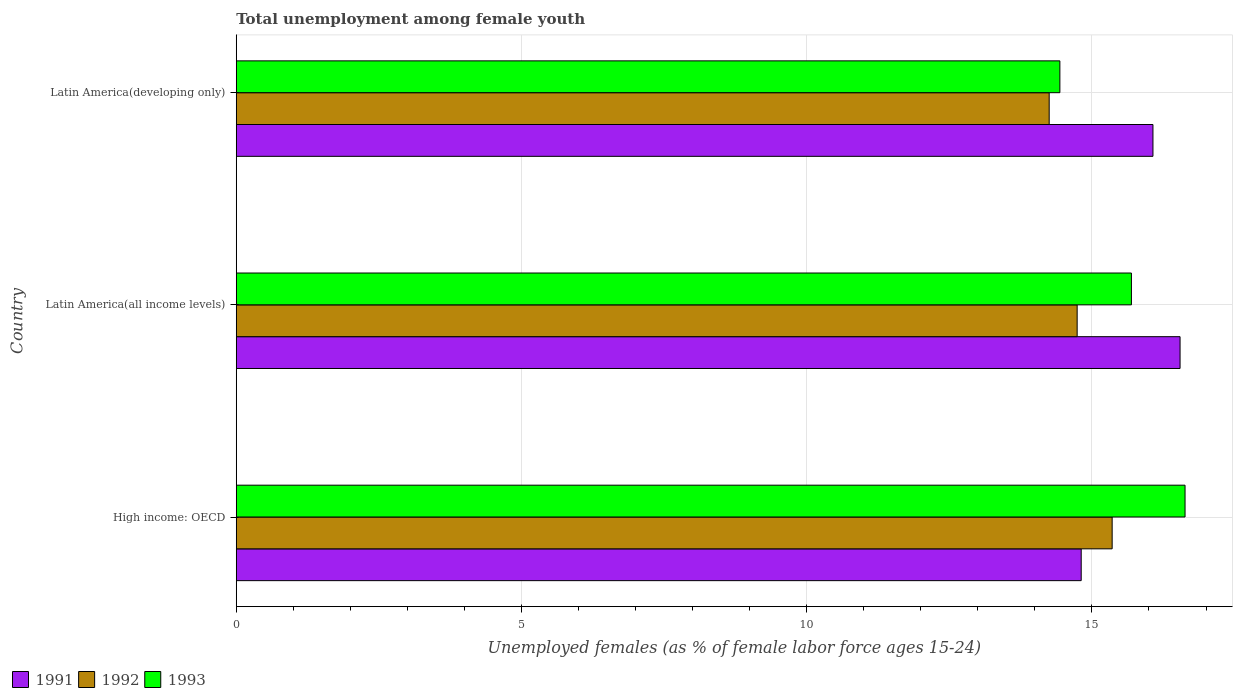How many groups of bars are there?
Give a very brief answer. 3. How many bars are there on the 2nd tick from the top?
Provide a succinct answer. 3. What is the label of the 2nd group of bars from the top?
Your answer should be very brief. Latin America(all income levels). What is the percentage of unemployed females in in 1992 in Latin America(all income levels)?
Make the answer very short. 14.74. Across all countries, what is the maximum percentage of unemployed females in in 1991?
Your answer should be very brief. 16.54. Across all countries, what is the minimum percentage of unemployed females in in 1992?
Offer a terse response. 14.25. In which country was the percentage of unemployed females in in 1992 maximum?
Your response must be concise. High income: OECD. In which country was the percentage of unemployed females in in 1992 minimum?
Offer a very short reply. Latin America(developing only). What is the total percentage of unemployed females in in 1993 in the graph?
Make the answer very short. 46.76. What is the difference between the percentage of unemployed females in in 1992 in High income: OECD and that in Latin America(all income levels)?
Your answer should be very brief. 0.61. What is the difference between the percentage of unemployed females in in 1992 in High income: OECD and the percentage of unemployed females in in 1991 in Latin America(developing only)?
Your answer should be compact. -0.72. What is the average percentage of unemployed females in in 1991 per country?
Keep it short and to the point. 15.81. What is the difference between the percentage of unemployed females in in 1991 and percentage of unemployed females in in 1993 in Latin America(developing only)?
Offer a terse response. 1.63. In how many countries, is the percentage of unemployed females in in 1993 greater than 15 %?
Your response must be concise. 2. What is the ratio of the percentage of unemployed females in in 1992 in High income: OECD to that in Latin America(developing only)?
Give a very brief answer. 1.08. Is the percentage of unemployed females in in 1992 in High income: OECD less than that in Latin America(all income levels)?
Your response must be concise. No. Is the difference between the percentage of unemployed females in in 1991 in High income: OECD and Latin America(developing only) greater than the difference between the percentage of unemployed females in in 1993 in High income: OECD and Latin America(developing only)?
Your response must be concise. No. What is the difference between the highest and the second highest percentage of unemployed females in in 1993?
Give a very brief answer. 0.94. What is the difference between the highest and the lowest percentage of unemployed females in in 1992?
Ensure brevity in your answer.  1.1. How many bars are there?
Make the answer very short. 9. Are all the bars in the graph horizontal?
Your answer should be compact. Yes. Does the graph contain grids?
Provide a short and direct response. Yes. What is the title of the graph?
Make the answer very short. Total unemployment among female youth. Does "1996" appear as one of the legend labels in the graph?
Your answer should be compact. No. What is the label or title of the X-axis?
Make the answer very short. Unemployed females (as % of female labor force ages 15-24). What is the label or title of the Y-axis?
Offer a terse response. Country. What is the Unemployed females (as % of female labor force ages 15-24) in 1991 in High income: OECD?
Make the answer very short. 14.81. What is the Unemployed females (as % of female labor force ages 15-24) of 1992 in High income: OECD?
Keep it short and to the point. 15.35. What is the Unemployed females (as % of female labor force ages 15-24) of 1993 in High income: OECD?
Offer a terse response. 16.63. What is the Unemployed females (as % of female labor force ages 15-24) of 1991 in Latin America(all income levels)?
Offer a very short reply. 16.54. What is the Unemployed females (as % of female labor force ages 15-24) of 1992 in Latin America(all income levels)?
Make the answer very short. 14.74. What is the Unemployed females (as % of female labor force ages 15-24) in 1993 in Latin America(all income levels)?
Offer a very short reply. 15.69. What is the Unemployed females (as % of female labor force ages 15-24) of 1991 in Latin America(developing only)?
Provide a short and direct response. 16.07. What is the Unemployed females (as % of female labor force ages 15-24) in 1992 in Latin America(developing only)?
Provide a succinct answer. 14.25. What is the Unemployed females (as % of female labor force ages 15-24) of 1993 in Latin America(developing only)?
Your answer should be compact. 14.44. Across all countries, what is the maximum Unemployed females (as % of female labor force ages 15-24) in 1991?
Your answer should be very brief. 16.54. Across all countries, what is the maximum Unemployed females (as % of female labor force ages 15-24) in 1992?
Your answer should be compact. 15.35. Across all countries, what is the maximum Unemployed females (as % of female labor force ages 15-24) in 1993?
Ensure brevity in your answer.  16.63. Across all countries, what is the minimum Unemployed females (as % of female labor force ages 15-24) of 1991?
Give a very brief answer. 14.81. Across all countries, what is the minimum Unemployed females (as % of female labor force ages 15-24) in 1992?
Your answer should be compact. 14.25. Across all countries, what is the minimum Unemployed females (as % of female labor force ages 15-24) of 1993?
Ensure brevity in your answer.  14.44. What is the total Unemployed females (as % of female labor force ages 15-24) of 1991 in the graph?
Your answer should be very brief. 47.43. What is the total Unemployed females (as % of female labor force ages 15-24) in 1992 in the graph?
Your answer should be compact. 44.35. What is the total Unemployed females (as % of female labor force ages 15-24) in 1993 in the graph?
Your response must be concise. 46.76. What is the difference between the Unemployed females (as % of female labor force ages 15-24) of 1991 in High income: OECD and that in Latin America(all income levels)?
Give a very brief answer. -1.73. What is the difference between the Unemployed females (as % of female labor force ages 15-24) in 1992 in High income: OECD and that in Latin America(all income levels)?
Your response must be concise. 0.61. What is the difference between the Unemployed females (as % of female labor force ages 15-24) in 1993 in High income: OECD and that in Latin America(all income levels)?
Make the answer very short. 0.94. What is the difference between the Unemployed females (as % of female labor force ages 15-24) of 1991 in High income: OECD and that in Latin America(developing only)?
Give a very brief answer. -1.26. What is the difference between the Unemployed females (as % of female labor force ages 15-24) in 1992 in High income: OECD and that in Latin America(developing only)?
Ensure brevity in your answer.  1.1. What is the difference between the Unemployed females (as % of female labor force ages 15-24) of 1993 in High income: OECD and that in Latin America(developing only)?
Ensure brevity in your answer.  2.19. What is the difference between the Unemployed females (as % of female labor force ages 15-24) in 1991 in Latin America(all income levels) and that in Latin America(developing only)?
Your answer should be very brief. 0.48. What is the difference between the Unemployed females (as % of female labor force ages 15-24) of 1992 in Latin America(all income levels) and that in Latin America(developing only)?
Provide a succinct answer. 0.49. What is the difference between the Unemployed females (as % of female labor force ages 15-24) of 1993 in Latin America(all income levels) and that in Latin America(developing only)?
Your answer should be compact. 1.25. What is the difference between the Unemployed females (as % of female labor force ages 15-24) in 1991 in High income: OECD and the Unemployed females (as % of female labor force ages 15-24) in 1992 in Latin America(all income levels)?
Offer a very short reply. 0.07. What is the difference between the Unemployed females (as % of female labor force ages 15-24) of 1991 in High income: OECD and the Unemployed females (as % of female labor force ages 15-24) of 1993 in Latin America(all income levels)?
Provide a succinct answer. -0.88. What is the difference between the Unemployed females (as % of female labor force ages 15-24) of 1992 in High income: OECD and the Unemployed females (as % of female labor force ages 15-24) of 1993 in Latin America(all income levels)?
Ensure brevity in your answer.  -0.34. What is the difference between the Unemployed females (as % of female labor force ages 15-24) in 1991 in High income: OECD and the Unemployed females (as % of female labor force ages 15-24) in 1992 in Latin America(developing only)?
Make the answer very short. 0.56. What is the difference between the Unemployed females (as % of female labor force ages 15-24) of 1991 in High income: OECD and the Unemployed females (as % of female labor force ages 15-24) of 1993 in Latin America(developing only)?
Give a very brief answer. 0.37. What is the difference between the Unemployed females (as % of female labor force ages 15-24) in 1992 in High income: OECD and the Unemployed females (as % of female labor force ages 15-24) in 1993 in Latin America(developing only)?
Ensure brevity in your answer.  0.92. What is the difference between the Unemployed females (as % of female labor force ages 15-24) in 1991 in Latin America(all income levels) and the Unemployed females (as % of female labor force ages 15-24) in 1992 in Latin America(developing only)?
Ensure brevity in your answer.  2.29. What is the difference between the Unemployed females (as % of female labor force ages 15-24) in 1991 in Latin America(all income levels) and the Unemployed females (as % of female labor force ages 15-24) in 1993 in Latin America(developing only)?
Provide a short and direct response. 2.11. What is the difference between the Unemployed females (as % of female labor force ages 15-24) of 1992 in Latin America(all income levels) and the Unemployed females (as % of female labor force ages 15-24) of 1993 in Latin America(developing only)?
Your answer should be very brief. 0.3. What is the average Unemployed females (as % of female labor force ages 15-24) in 1991 per country?
Offer a very short reply. 15.81. What is the average Unemployed females (as % of female labor force ages 15-24) of 1992 per country?
Your response must be concise. 14.78. What is the average Unemployed females (as % of female labor force ages 15-24) in 1993 per country?
Ensure brevity in your answer.  15.59. What is the difference between the Unemployed females (as % of female labor force ages 15-24) of 1991 and Unemployed females (as % of female labor force ages 15-24) of 1992 in High income: OECD?
Offer a terse response. -0.54. What is the difference between the Unemployed females (as % of female labor force ages 15-24) in 1991 and Unemployed females (as % of female labor force ages 15-24) in 1993 in High income: OECD?
Offer a terse response. -1.82. What is the difference between the Unemployed females (as % of female labor force ages 15-24) of 1992 and Unemployed females (as % of female labor force ages 15-24) of 1993 in High income: OECD?
Give a very brief answer. -1.28. What is the difference between the Unemployed females (as % of female labor force ages 15-24) in 1991 and Unemployed females (as % of female labor force ages 15-24) in 1992 in Latin America(all income levels)?
Your answer should be compact. 1.8. What is the difference between the Unemployed females (as % of female labor force ages 15-24) of 1991 and Unemployed females (as % of female labor force ages 15-24) of 1993 in Latin America(all income levels)?
Your answer should be very brief. 0.85. What is the difference between the Unemployed females (as % of female labor force ages 15-24) in 1992 and Unemployed females (as % of female labor force ages 15-24) in 1993 in Latin America(all income levels)?
Give a very brief answer. -0.95. What is the difference between the Unemployed females (as % of female labor force ages 15-24) of 1991 and Unemployed females (as % of female labor force ages 15-24) of 1992 in Latin America(developing only)?
Your answer should be very brief. 1.82. What is the difference between the Unemployed females (as % of female labor force ages 15-24) of 1991 and Unemployed females (as % of female labor force ages 15-24) of 1993 in Latin America(developing only)?
Give a very brief answer. 1.63. What is the difference between the Unemployed females (as % of female labor force ages 15-24) in 1992 and Unemployed females (as % of female labor force ages 15-24) in 1993 in Latin America(developing only)?
Provide a short and direct response. -0.19. What is the ratio of the Unemployed females (as % of female labor force ages 15-24) of 1991 in High income: OECD to that in Latin America(all income levels)?
Offer a terse response. 0.9. What is the ratio of the Unemployed females (as % of female labor force ages 15-24) in 1992 in High income: OECD to that in Latin America(all income levels)?
Your answer should be very brief. 1.04. What is the ratio of the Unemployed females (as % of female labor force ages 15-24) of 1993 in High income: OECD to that in Latin America(all income levels)?
Your answer should be very brief. 1.06. What is the ratio of the Unemployed females (as % of female labor force ages 15-24) in 1991 in High income: OECD to that in Latin America(developing only)?
Your answer should be very brief. 0.92. What is the ratio of the Unemployed females (as % of female labor force ages 15-24) of 1992 in High income: OECD to that in Latin America(developing only)?
Ensure brevity in your answer.  1.08. What is the ratio of the Unemployed females (as % of female labor force ages 15-24) of 1993 in High income: OECD to that in Latin America(developing only)?
Ensure brevity in your answer.  1.15. What is the ratio of the Unemployed females (as % of female labor force ages 15-24) of 1991 in Latin America(all income levels) to that in Latin America(developing only)?
Your answer should be very brief. 1.03. What is the ratio of the Unemployed females (as % of female labor force ages 15-24) of 1992 in Latin America(all income levels) to that in Latin America(developing only)?
Your answer should be very brief. 1.03. What is the ratio of the Unemployed females (as % of female labor force ages 15-24) in 1993 in Latin America(all income levels) to that in Latin America(developing only)?
Provide a short and direct response. 1.09. What is the difference between the highest and the second highest Unemployed females (as % of female labor force ages 15-24) of 1991?
Your response must be concise. 0.48. What is the difference between the highest and the second highest Unemployed females (as % of female labor force ages 15-24) of 1992?
Give a very brief answer. 0.61. What is the difference between the highest and the second highest Unemployed females (as % of female labor force ages 15-24) of 1993?
Give a very brief answer. 0.94. What is the difference between the highest and the lowest Unemployed females (as % of female labor force ages 15-24) in 1991?
Keep it short and to the point. 1.73. What is the difference between the highest and the lowest Unemployed females (as % of female labor force ages 15-24) of 1992?
Your response must be concise. 1.1. What is the difference between the highest and the lowest Unemployed females (as % of female labor force ages 15-24) in 1993?
Your response must be concise. 2.19. 